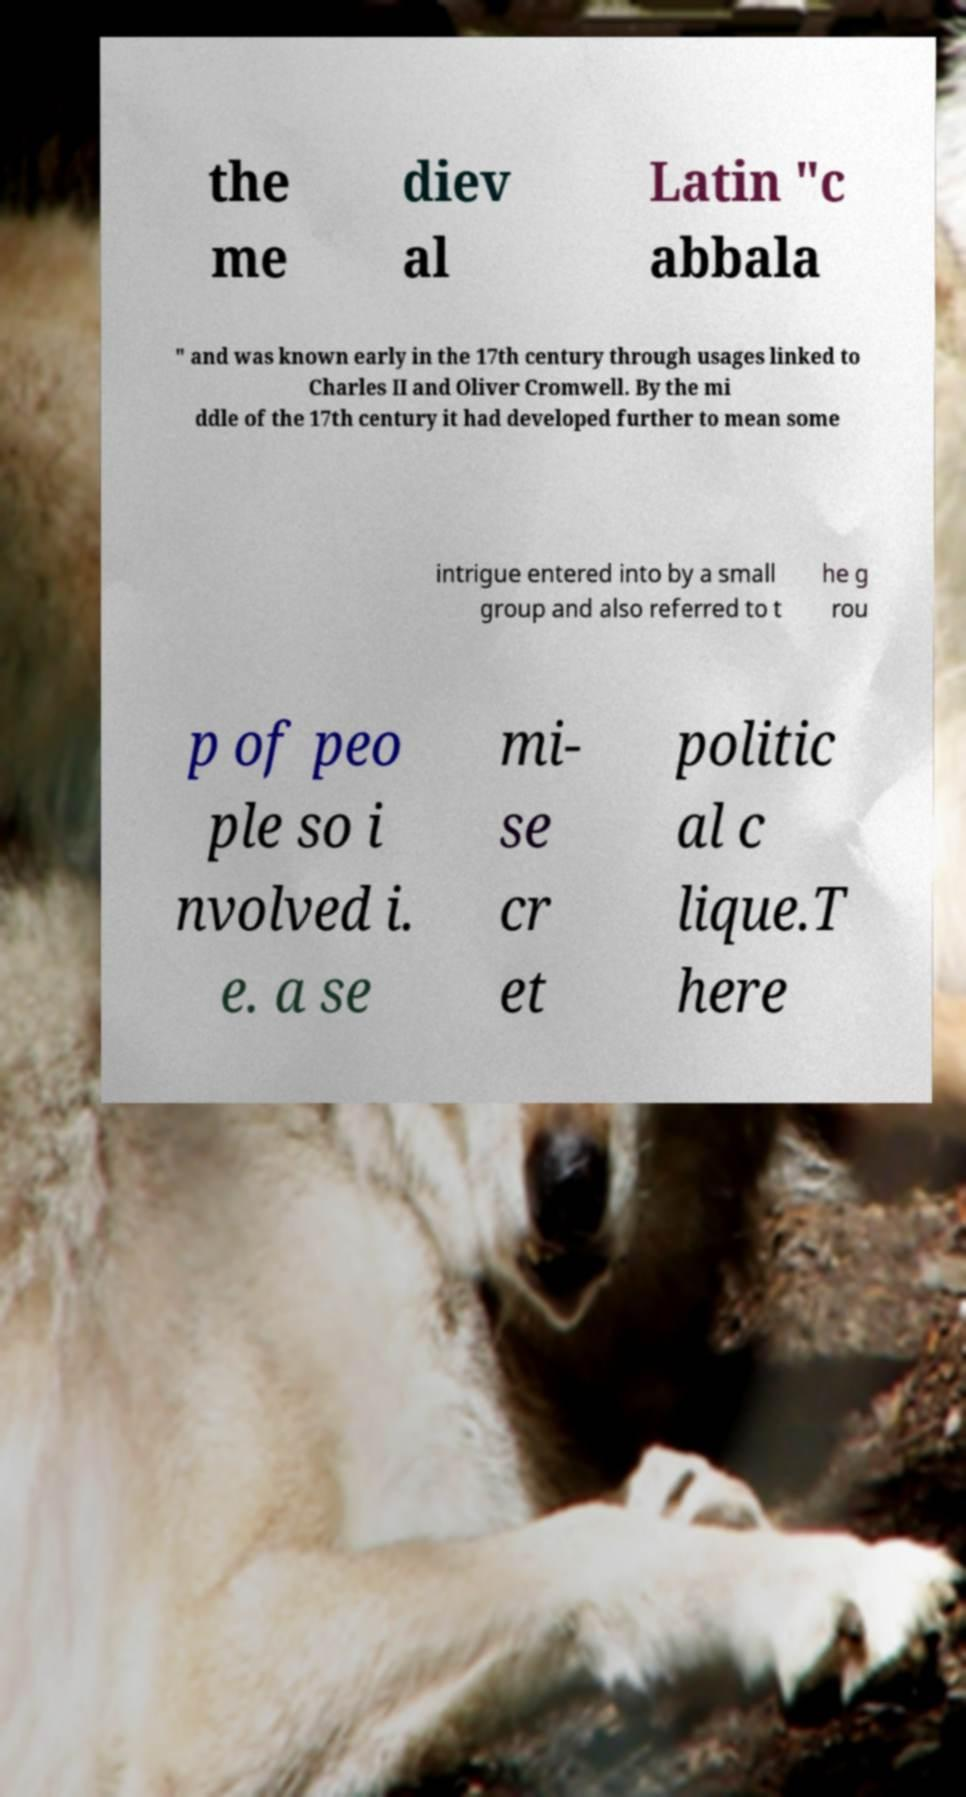Please read and relay the text visible in this image. What does it say? the me diev al Latin "c abbala " and was known early in the 17th century through usages linked to Charles II and Oliver Cromwell. By the mi ddle of the 17th century it had developed further to mean some intrigue entered into by a small group and also referred to t he g rou p of peo ple so i nvolved i. e. a se mi- se cr et politic al c lique.T here 